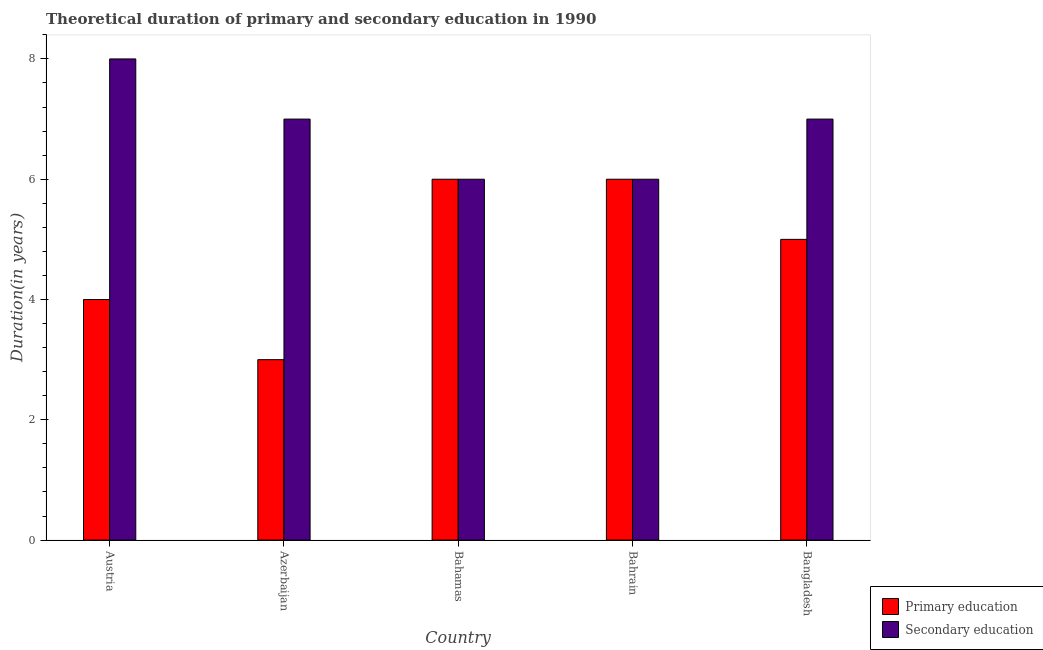How many groups of bars are there?
Ensure brevity in your answer.  5. Are the number of bars on each tick of the X-axis equal?
Your answer should be compact. Yes. How many bars are there on the 4th tick from the left?
Your answer should be compact. 2. What is the label of the 5th group of bars from the left?
Provide a short and direct response. Bangladesh. Across all countries, what is the maximum duration of secondary education?
Your answer should be compact. 8. Across all countries, what is the minimum duration of primary education?
Provide a short and direct response. 3. In which country was the duration of primary education maximum?
Keep it short and to the point. Bahamas. In which country was the duration of primary education minimum?
Provide a succinct answer. Azerbaijan. What is the total duration of secondary education in the graph?
Make the answer very short. 34. What is the difference between the duration of primary education in Bahrain and that in Bangladesh?
Provide a succinct answer. 1. What is the difference between the duration of primary education in Bahamas and the duration of secondary education in Austria?
Make the answer very short. -2. What is the difference between the duration of secondary education and duration of primary education in Austria?
Give a very brief answer. 4. What is the ratio of the duration of primary education in Austria to that in Azerbaijan?
Give a very brief answer. 1.33. Is the duration of secondary education in Austria less than that in Bangladesh?
Your answer should be very brief. No. What is the difference between the highest and the lowest duration of primary education?
Your response must be concise. 3. Is the sum of the duration of secondary education in Azerbaijan and Bahrain greater than the maximum duration of primary education across all countries?
Keep it short and to the point. Yes. What does the 2nd bar from the left in Bahamas represents?
Give a very brief answer. Secondary education. What does the 2nd bar from the right in Austria represents?
Keep it short and to the point. Primary education. How many bars are there?
Offer a terse response. 10. How many countries are there in the graph?
Ensure brevity in your answer.  5. Does the graph contain grids?
Offer a very short reply. No. Where does the legend appear in the graph?
Ensure brevity in your answer.  Bottom right. What is the title of the graph?
Make the answer very short. Theoretical duration of primary and secondary education in 1990. What is the label or title of the X-axis?
Offer a very short reply. Country. What is the label or title of the Y-axis?
Your answer should be compact. Duration(in years). What is the Duration(in years) in Primary education in Azerbaijan?
Offer a very short reply. 3. What is the Duration(in years) in Secondary education in Bangladesh?
Your answer should be very brief. 7. Across all countries, what is the maximum Duration(in years) in Secondary education?
Ensure brevity in your answer.  8. What is the difference between the Duration(in years) in Primary education in Austria and that in Azerbaijan?
Offer a terse response. 1. What is the difference between the Duration(in years) of Secondary education in Austria and that in Azerbaijan?
Provide a succinct answer. 1. What is the difference between the Duration(in years) of Secondary education in Austria and that in Bahrain?
Offer a very short reply. 2. What is the difference between the Duration(in years) in Primary education in Austria and that in Bangladesh?
Your answer should be very brief. -1. What is the difference between the Duration(in years) of Secondary education in Austria and that in Bangladesh?
Your answer should be very brief. 1. What is the difference between the Duration(in years) in Primary education in Azerbaijan and that in Bahrain?
Your answer should be compact. -3. What is the difference between the Duration(in years) in Secondary education in Azerbaijan and that in Bahrain?
Your response must be concise. 1. What is the difference between the Duration(in years) of Secondary education in Azerbaijan and that in Bangladesh?
Provide a short and direct response. 0. What is the difference between the Duration(in years) of Secondary education in Bahamas and that in Bahrain?
Give a very brief answer. 0. What is the difference between the Duration(in years) of Secondary education in Bahamas and that in Bangladesh?
Your response must be concise. -1. What is the difference between the Duration(in years) of Primary education in Bahrain and that in Bangladesh?
Give a very brief answer. 1. What is the difference between the Duration(in years) of Secondary education in Bahrain and that in Bangladesh?
Ensure brevity in your answer.  -1. What is the difference between the Duration(in years) in Primary education in Austria and the Duration(in years) in Secondary education in Bangladesh?
Your response must be concise. -3. What is the difference between the Duration(in years) of Primary education in Azerbaijan and the Duration(in years) of Secondary education in Bahrain?
Keep it short and to the point. -3. What is the difference between the Duration(in years) in Primary education in Bahrain and the Duration(in years) in Secondary education in Bangladesh?
Give a very brief answer. -1. What is the average Duration(in years) in Primary education per country?
Your response must be concise. 4.8. What is the difference between the Duration(in years) of Primary education and Duration(in years) of Secondary education in Austria?
Keep it short and to the point. -4. What is the difference between the Duration(in years) in Primary education and Duration(in years) in Secondary education in Azerbaijan?
Your answer should be compact. -4. What is the difference between the Duration(in years) of Primary education and Duration(in years) of Secondary education in Bahrain?
Ensure brevity in your answer.  0. What is the ratio of the Duration(in years) in Secondary education in Austria to that in Azerbaijan?
Offer a very short reply. 1.14. What is the ratio of the Duration(in years) in Primary education in Austria to that in Bahamas?
Your response must be concise. 0.67. What is the ratio of the Duration(in years) of Primary education in Azerbaijan to that in Bahrain?
Ensure brevity in your answer.  0.5. What is the ratio of the Duration(in years) of Primary education in Azerbaijan to that in Bangladesh?
Give a very brief answer. 0.6. What is the ratio of the Duration(in years) in Secondary education in Azerbaijan to that in Bangladesh?
Make the answer very short. 1. What is the ratio of the Duration(in years) in Secondary education in Bahamas to that in Bahrain?
Offer a very short reply. 1. What is the ratio of the Duration(in years) of Primary education in Bahamas to that in Bangladesh?
Keep it short and to the point. 1.2. What is the ratio of the Duration(in years) in Secondary education in Bahamas to that in Bangladesh?
Make the answer very short. 0.86. What is the ratio of the Duration(in years) in Primary education in Bahrain to that in Bangladesh?
Keep it short and to the point. 1.2. What is the difference between the highest and the lowest Duration(in years) of Primary education?
Your response must be concise. 3. What is the difference between the highest and the lowest Duration(in years) in Secondary education?
Your answer should be compact. 2. 